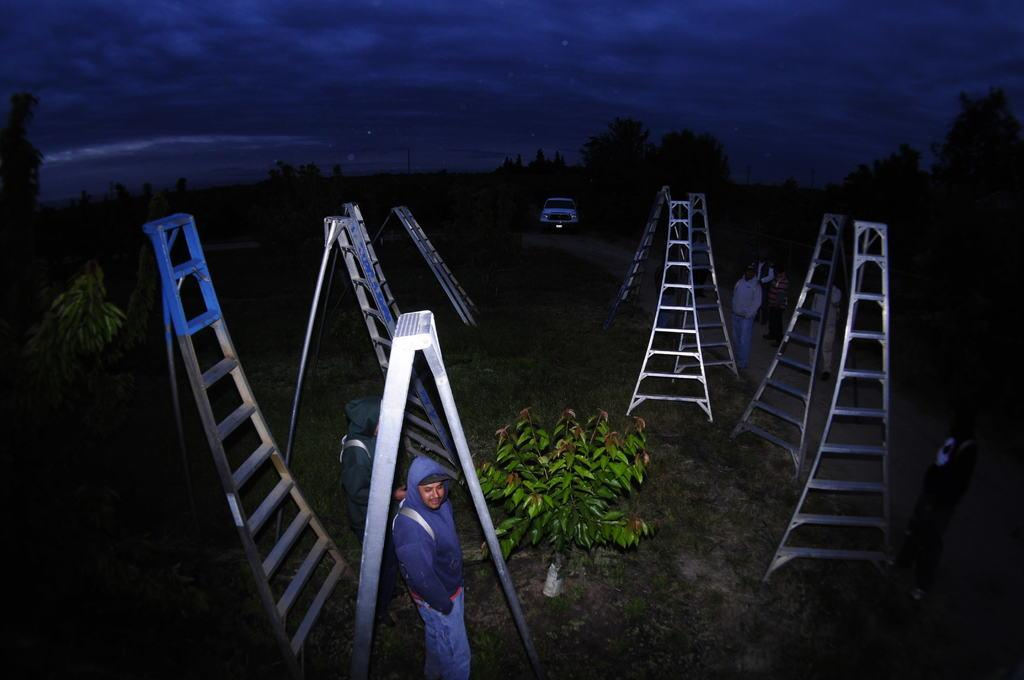What are the people in the image doing? There are groups of people standing in the image. What objects can be seen in the image that might be used for climbing or reaching higher places? There are ladders in the image. What type of natural elements are present in the image? There are trees and plants in the image. What mode of transportation can be seen in the image? There is a car in the image. What is visible in the background of the image? The sky is visible in the image. What type of wound can be seen on the toes of the person in the image? There are no visible people or body parts in the image, so it is not possible to determine if there are any wounds on anyone's toes. 